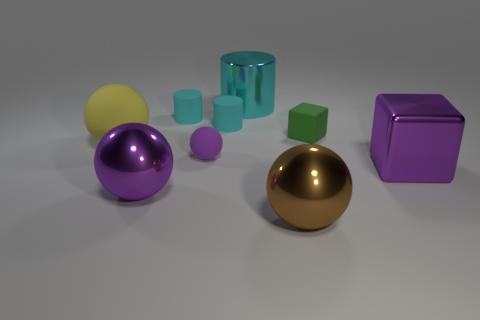What is the shape of the purple thing that is to the right of the metallic sphere that is to the right of the cyan metal cylinder?
Provide a short and direct response. Cube. Are there any things that have the same size as the yellow sphere?
Provide a short and direct response. Yes. How many other green rubber things have the same shape as the green rubber object?
Offer a terse response. 0. Are there the same number of shiny objects left of the small green block and large metal cylinders that are on the left side of the purple matte object?
Your answer should be compact. No. Are any brown metallic objects visible?
Offer a very short reply. Yes. There is a metallic ball to the right of the big metallic object that is behind the purple metal object right of the brown metallic sphere; what size is it?
Offer a very short reply. Large. What is the shape of the cyan object that is the same size as the brown thing?
Your answer should be very brief. Cylinder. How many things are either tiny objects that are right of the big cyan shiny cylinder or green matte blocks?
Provide a succinct answer. 1. There is a tiny matte cylinder on the right side of the rubber sphere that is on the right side of the large rubber sphere; is there a purple matte object to the right of it?
Keep it short and to the point. No. What number of big purple metallic balls are there?
Your answer should be very brief. 1. 